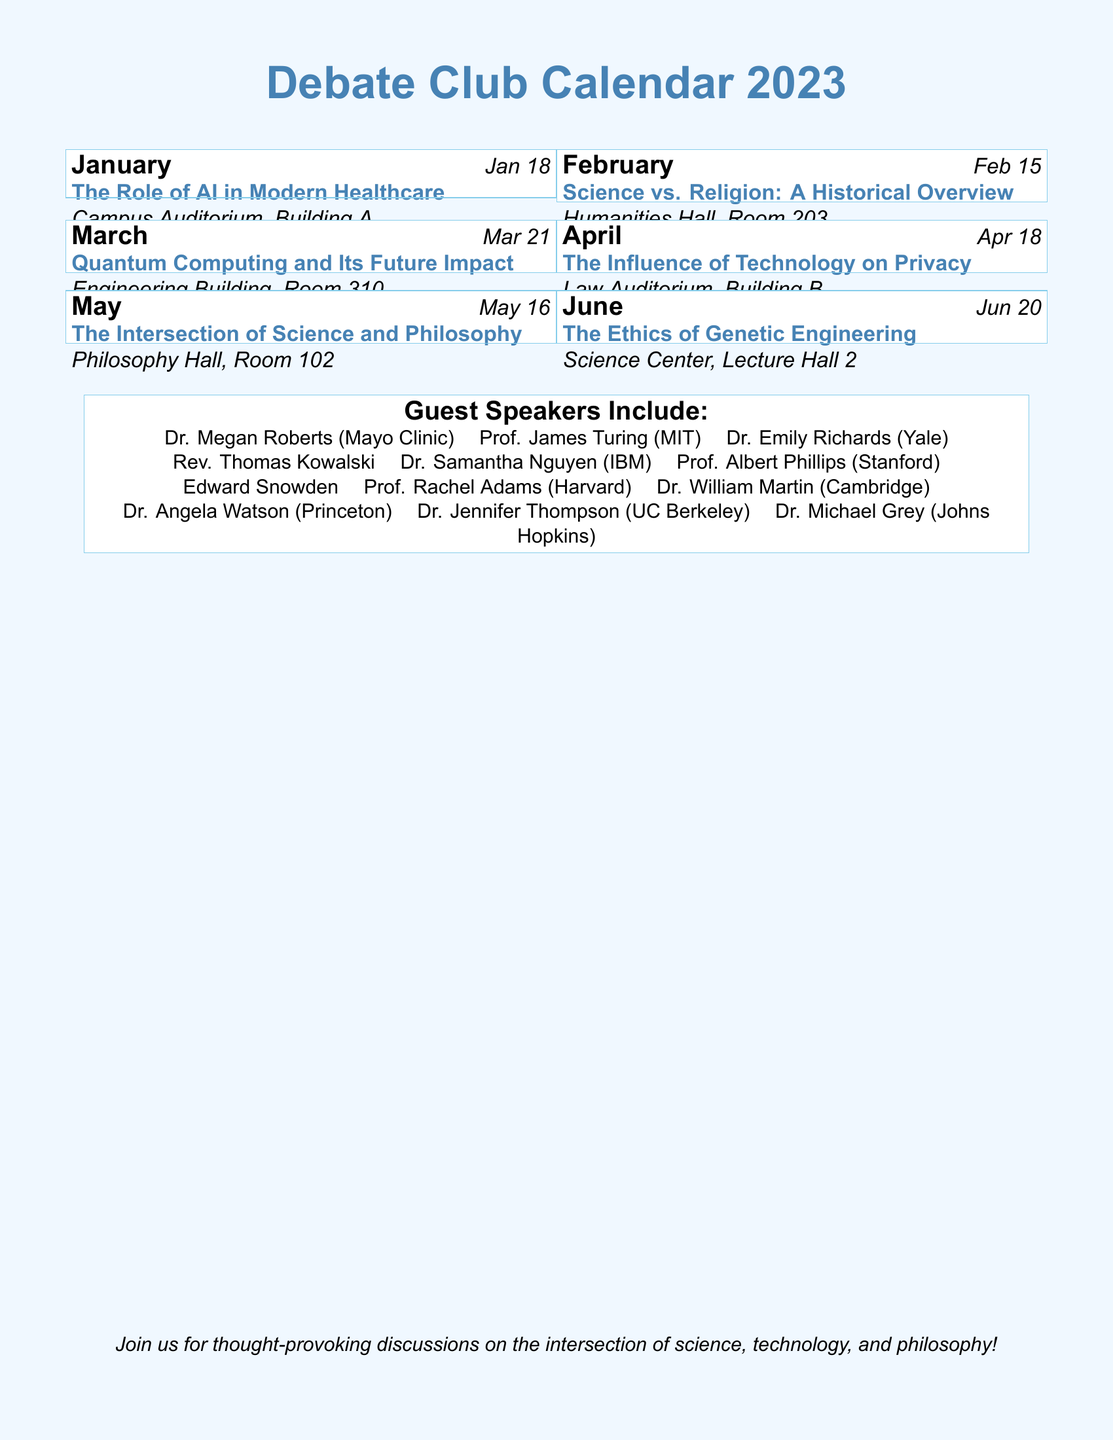What is the topic for February? The document lists the topic for February, which is "Science vs. Religion: A Historical Overview."
Answer: Science vs. Religion: A Historical Overview When is the debate on Quantum Computing scheduled? The date for the Quantum Computing debate is mentioned as March 21.
Answer: Mar 21 How many total debate topics are listed in the document? By counting the topics listed for each month, there are a total of six debate topics.
Answer: 6 Where will the debate on The Ethics of Genetic Engineering take place? The document specifies that the location for this debate is "Science Center, Lecture Hall 2."
Answer: Science Center, Lecture Hall 2 Who is one of the guest speakers associated with genetic engineering? The guest speaker list includes Dr. Samantha Nguyen, who is associated with IBM, relevant to genetic engineering ethics.
Answer: Dr. Samantha Nguyen Which month features a debate about Privacy? The month associated with the debate on privacy is April, as indicated in the document.
Answer: April What is the main theme of the May debate? May's theme is "The Intersection of Science and Philosophy," as noted in the calendar.
Answer: The Intersection of Science and Philosophy Is there a guest speaker from Harvard? The document includes Prof. Rachel Adams from Harvard as a guest speaker.
Answer: Prof. Rachel Adams What is the venue for the January debate? The January debate will take place at "Campus Auditorium, Building A," as stated in the document.
Answer: Campus Auditorium, Building A 